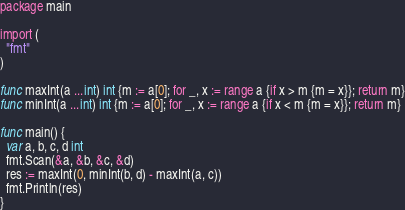Convert code to text. <code><loc_0><loc_0><loc_500><loc_500><_Go_>package main

import (
  "fmt"
)

func maxInt(a ...int) int {m := a[0]; for _, x := range a {if x > m {m = x}}; return m}
func minInt(a ...int) int {m := a[0]; for _, x := range a {if x < m {m = x}}; return m}

func main() {
  var a, b, c, d int 
  fmt.Scan(&a, &b, &c, &d)
  res := maxInt(0, minInt(b, d) - maxInt(a, c))
  fmt.Println(res)
}</code> 